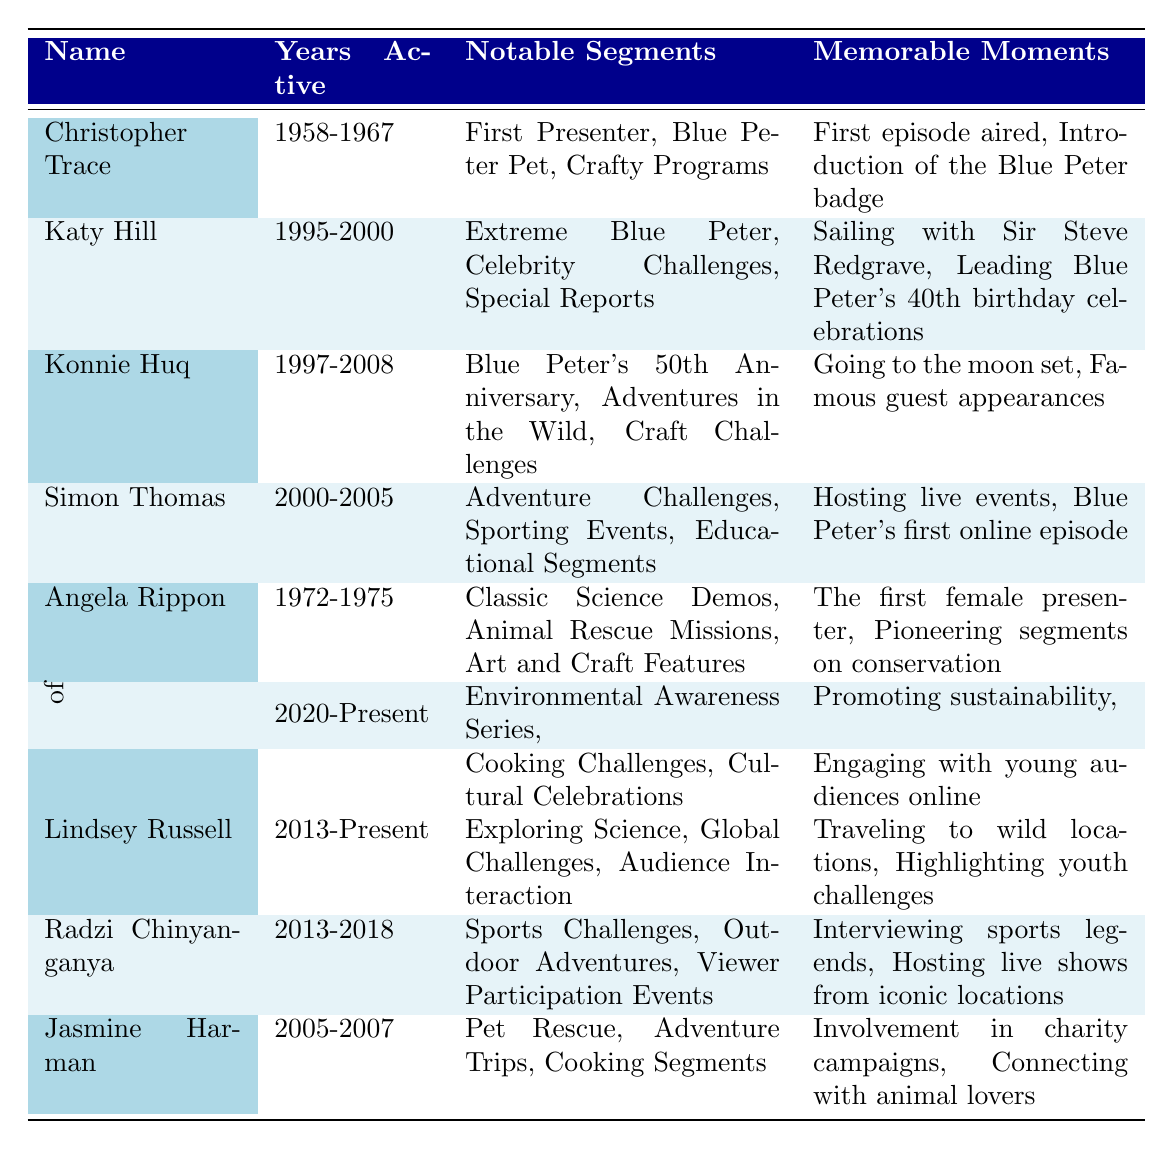What years was Konnie Huq active as a presenter? According to the table, Konnie Huq was active from 1997 to 2008.
Answer: 1997-2008 Which presenter was known as the first female presenter on Blue Peter? The table indicates that Angela Rippon was the first female presenter.
Answer: Angela Rippon How many notable segments did Lindsey Russell have during her active years? The table lists three notable segments for Lindsey Russell: Exploring Science, Global Challenges, and Audience Interaction.
Answer: 3 Did Simon Thomas host any educational segments? Yes, the table states that Simon Thomas was involved in Educational Segments as one of his notable segments.
Answer: Yes Who hosted live events and also had the Blue Peter's first online episode as a memorable moment? The table shows that Simon Thomas hosted live events and is also associated with Blue Peter's first online episode.
Answer: Simon Thomas Which two presenters were active in the 2000s and had notable segments related to adventure? The table displays that both Simon Thomas (2000-2005) and Jasmine Harman (2005-2007) had notable segments related to adventure, with Simon focusing on Adventure Challenges and Jasmine on Adventure Trips.
Answer: Simon Thomas and Jasmine Harman What is the difference in the years of activity between Christopher Trace and Katy Hill? Christopher Trace was active from 1958 to 1967 (9 years), while Katy Hill was active from 1995 to 2000 (5 years). The difference is 9 - 5 = 4 years.
Answer: 4 years How many presenters were active from 2010 onwards? The table mentions three presenters active from 2010 onwards: Lindsey Russell (2013-Present), Radzi Chinyanganya (2013-2018), and Presenters of the 2020s (2020-Present). Therefore, there are 3 presenters in this range.
Answer: 3 In which decade did Angela Rippon serve as a presenter? Angela Rippon was active from 1972 to 1975, which falls in the 1970s decade.
Answer: 1970s 